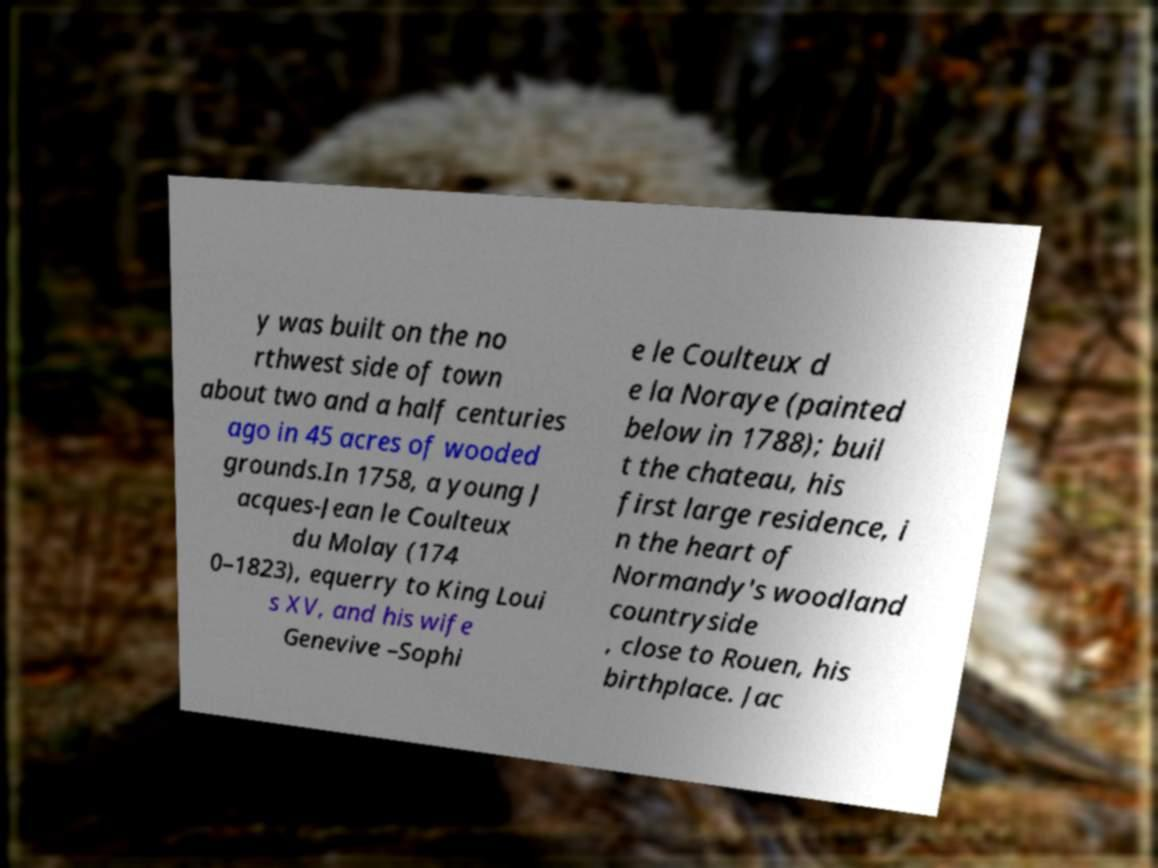There's text embedded in this image that I need extracted. Can you transcribe it verbatim? y was built on the no rthwest side of town about two and a half centuries ago in 45 acres of wooded grounds.In 1758, a young J acques-Jean le Coulteux du Molay (174 0–1823), equerry to King Loui s XV, and his wife Genevive –Sophi e le Coulteux d e la Noraye (painted below in 1788); buil t the chateau, his first large residence, i n the heart of Normandy's woodland countryside , close to Rouen, his birthplace. Jac 